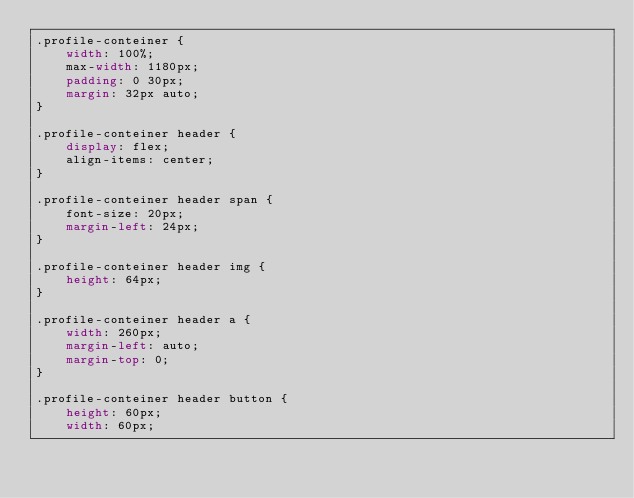Convert code to text. <code><loc_0><loc_0><loc_500><loc_500><_CSS_>.profile-conteiner {
    width: 100%;
    max-width: 1180px;
    padding: 0 30px;
    margin: 32px auto;
}

.profile-conteiner header {
    display: flex;
    align-items: center;
}

.profile-conteiner header span {
    font-size: 20px;
    margin-left: 24px;
}

.profile-conteiner header img {
    height: 64px;
}

.profile-conteiner header a {
    width: 260px;
    margin-left: auto;
    margin-top: 0;
}

.profile-conteiner header button {
    height: 60px;
    width: 60px;</code> 